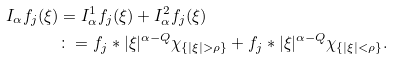Convert formula to latex. <formula><loc_0><loc_0><loc_500><loc_500>I _ { \alpha } f _ { j } ( \xi ) & = I _ { \alpha } ^ { 1 } f _ { j } ( \xi ) + I _ { \alpha } ^ { 2 } f _ { j } ( \xi ) \\ & \colon = f _ { j } * | \xi | ^ { \alpha - Q } \chi _ { \{ | \xi | > \rho \} } + f _ { j } * | \xi | ^ { \alpha - Q } \chi _ { \{ | \xi | < \rho \} } .</formula> 